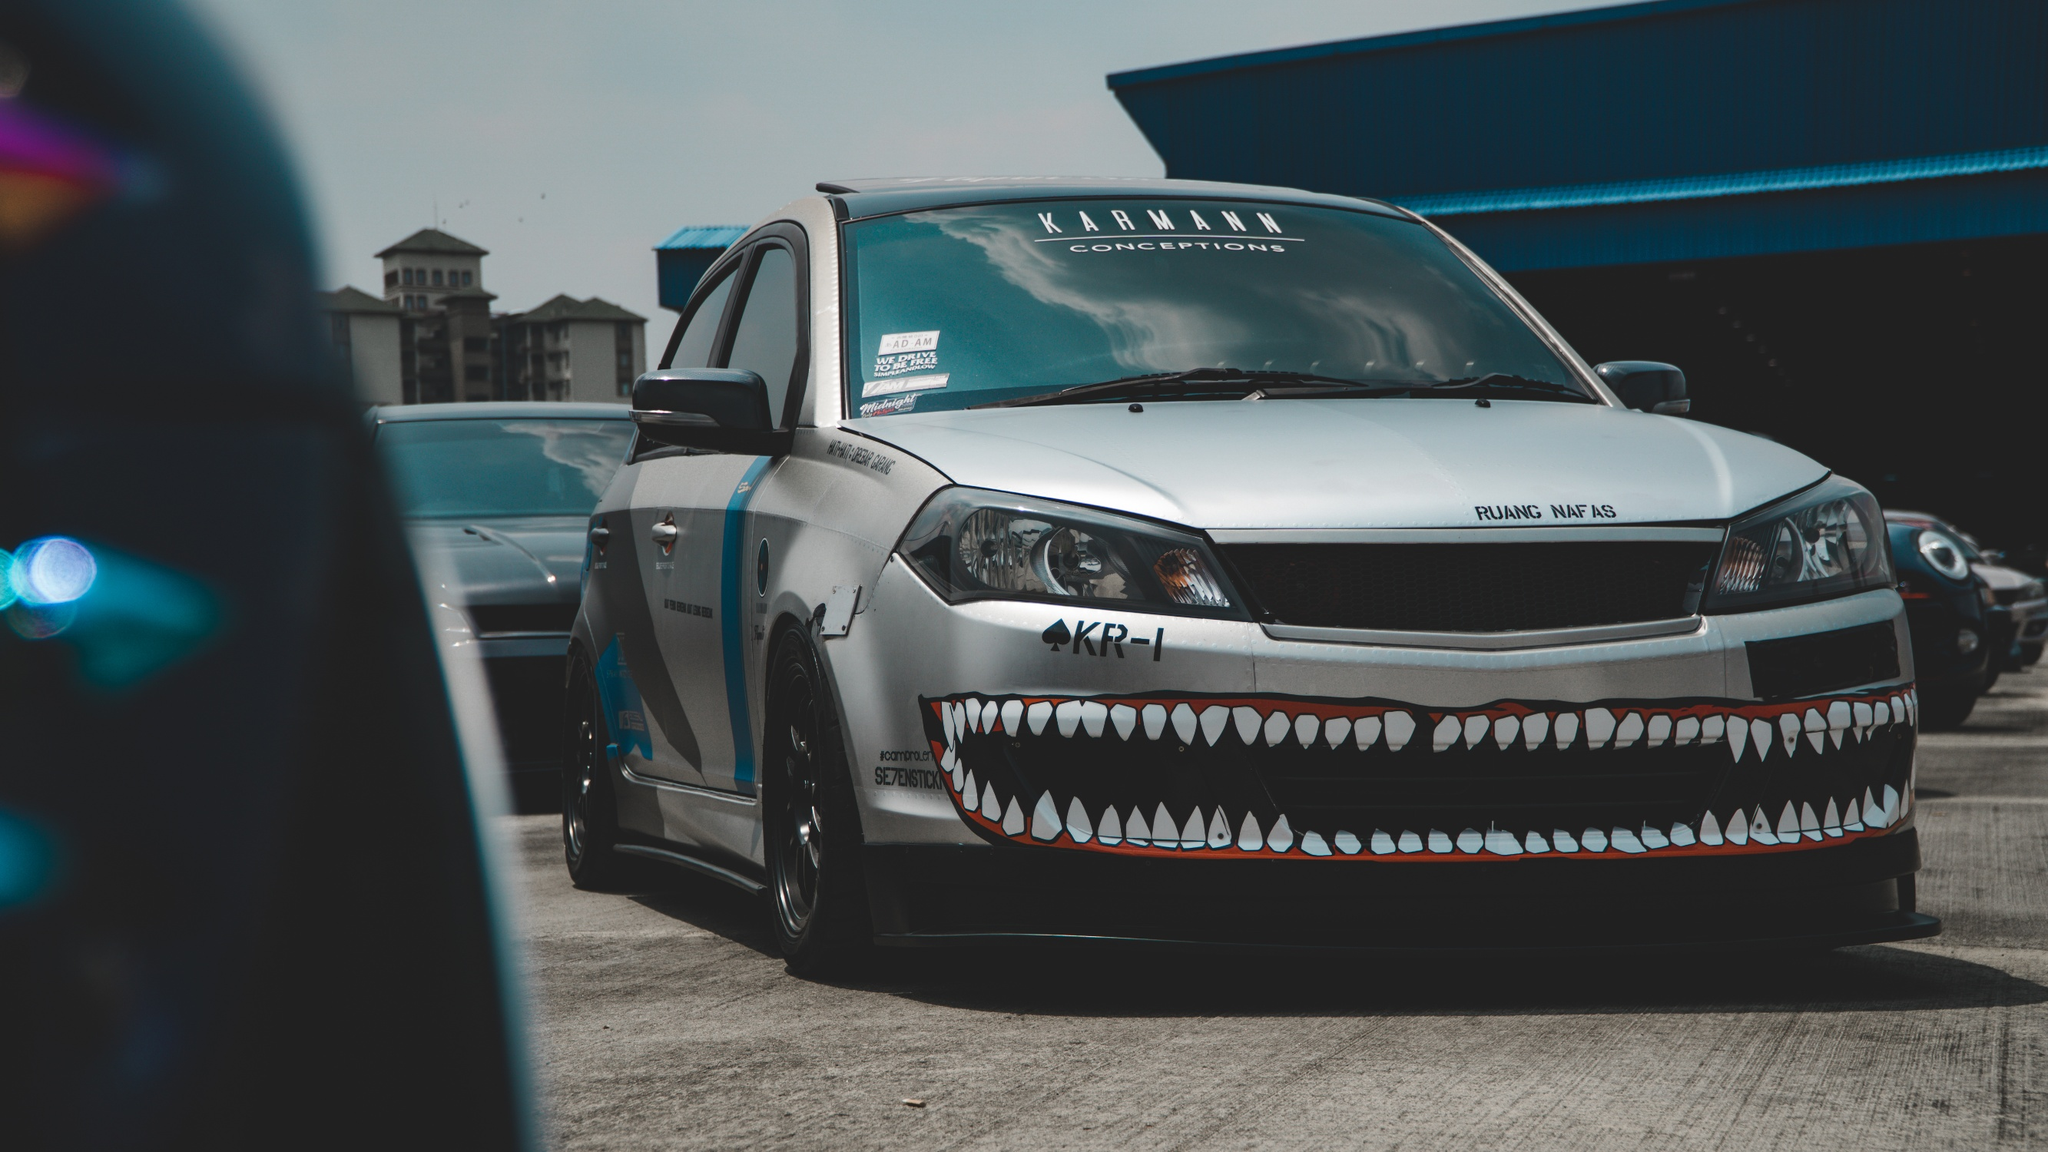Can you tell a story about the car's journey that led it to this parking lot? This car, affectionately known as 'The Shark', has a storied past. Originally purchased as a standard model, the owner—a car enthusiast with a penchant for customization—saw potential in its sleek lines and robust build. Over the course of several months, 'The Shark' underwent a dramatic transformation. Starting with the striking teeth design, which was inspired by World War II fighter planes, the owner meticulously painted each sharp tooth by hand, ensuring that the car's aggressive personality was unmistakably clear. The customizations didn't stop there; under the hood, 'The Shark' boasts a powerful engine upgrade, allowing it to roar down the highways with the speed and grace of its namesake. Having participated in numerous car shows, 'The Shark' has won accolades for its unique appearance and performance. Today, parked in the lot, 'The Shark' is taking a breather before its next adventure—perhaps another car show, a race, or simply cruising the city streets, turning heads wherever it goes. 